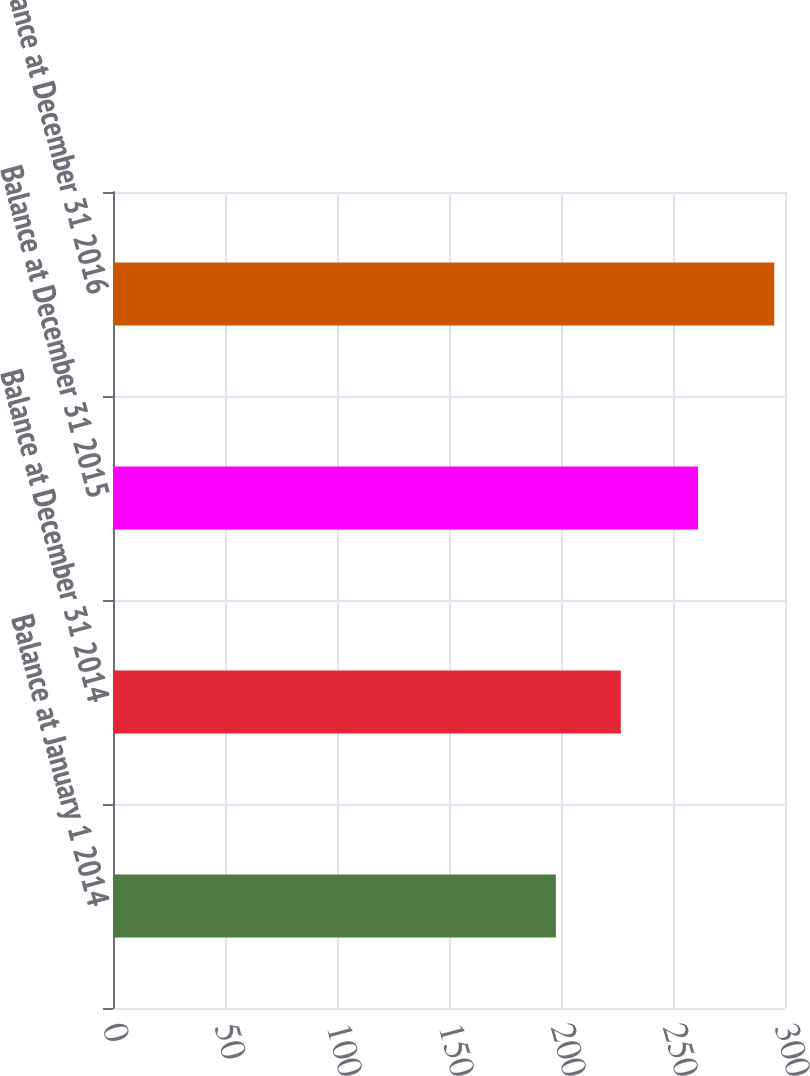Convert chart to OTSL. <chart><loc_0><loc_0><loc_500><loc_500><bar_chart><fcel>Balance at January 1 2014<fcel>Balance at December 31 2014<fcel>Balance at December 31 2015<fcel>Balance at December 31 2016<nl><fcel>197.7<fcel>226.7<fcel>261.2<fcel>295.2<nl></chart> 